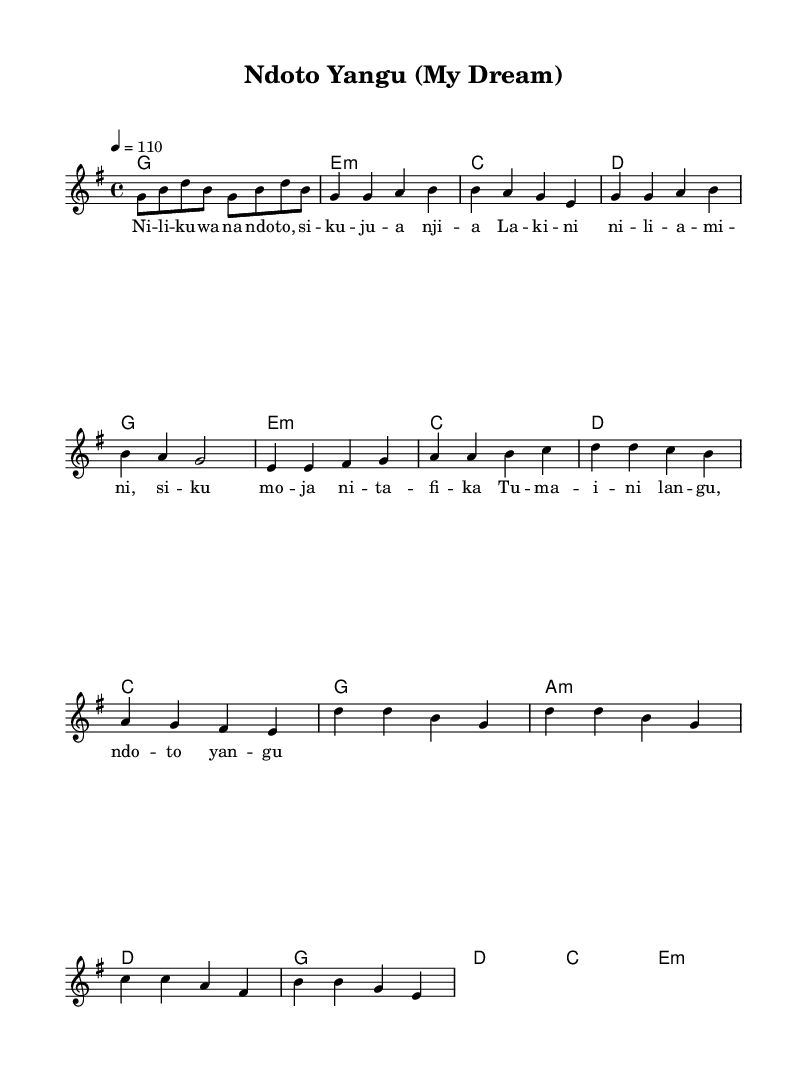What is the key signature of this music? The key signature is G major, which has one sharp (F#). This can be determined by identifying the key indicated at the beginning of the sheet music.
Answer: G major What is the time signature of the piece? The time signature is 4/4, which is noted at the beginning of the sheet music. This indicates that there are four beats in a measure and the quarter note receives one beat.
Answer: 4/4 What is the tempo marking of this music? The tempo marking is 110 beats per minute, indicated by the tempo notation. This tells the performer how fast to play the piece.
Answer: 110 How many measures are in the chorus? The chorus consists of four measures, which can be counted from the notation labeled as "Chorus". Each line of music corresponds to a measure in the sheet music.
Answer: 4 What chord follows the melody note in measure 1? The chord following the melody note in measure 1 is G major, as indicated by the chord symbols above the staff. This reflects the harmony that supports the melody.
Answer: G Which theme does this song reflect regarding overcoming challenges? The theme reflected in the song is about dreams and perseverance in the face of challenges, as evidenced by the lyrics that speak of dreams and hope. This can be inferred from the text of the lyrics provided in the sheet music.
Answer: Dreams and perseverance 